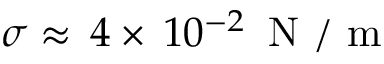<formula> <loc_0><loc_0><loc_500><loc_500>\sigma \approx \, 4 \times \, 1 0 ^ { - 2 } \, N / m</formula> 